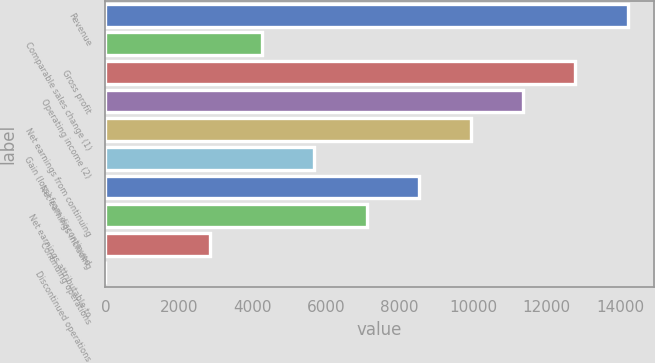<chart> <loc_0><loc_0><loc_500><loc_500><bar_chart><fcel>Revenue<fcel>Comparable sales change (1)<fcel>Gross profit<fcel>Operating income (2)<fcel>Net earnings from continuing<fcel>Gain (loss) from discontinued<fcel>Net earnings including<fcel>Net earnings attributable to<fcel>Continuing operations<fcel>Discontinued operations<nl><fcel>14209<fcel>4262.71<fcel>12788.1<fcel>11367.2<fcel>9946.31<fcel>5683.61<fcel>8525.41<fcel>7104.51<fcel>2841.81<fcel>0.01<nl></chart> 